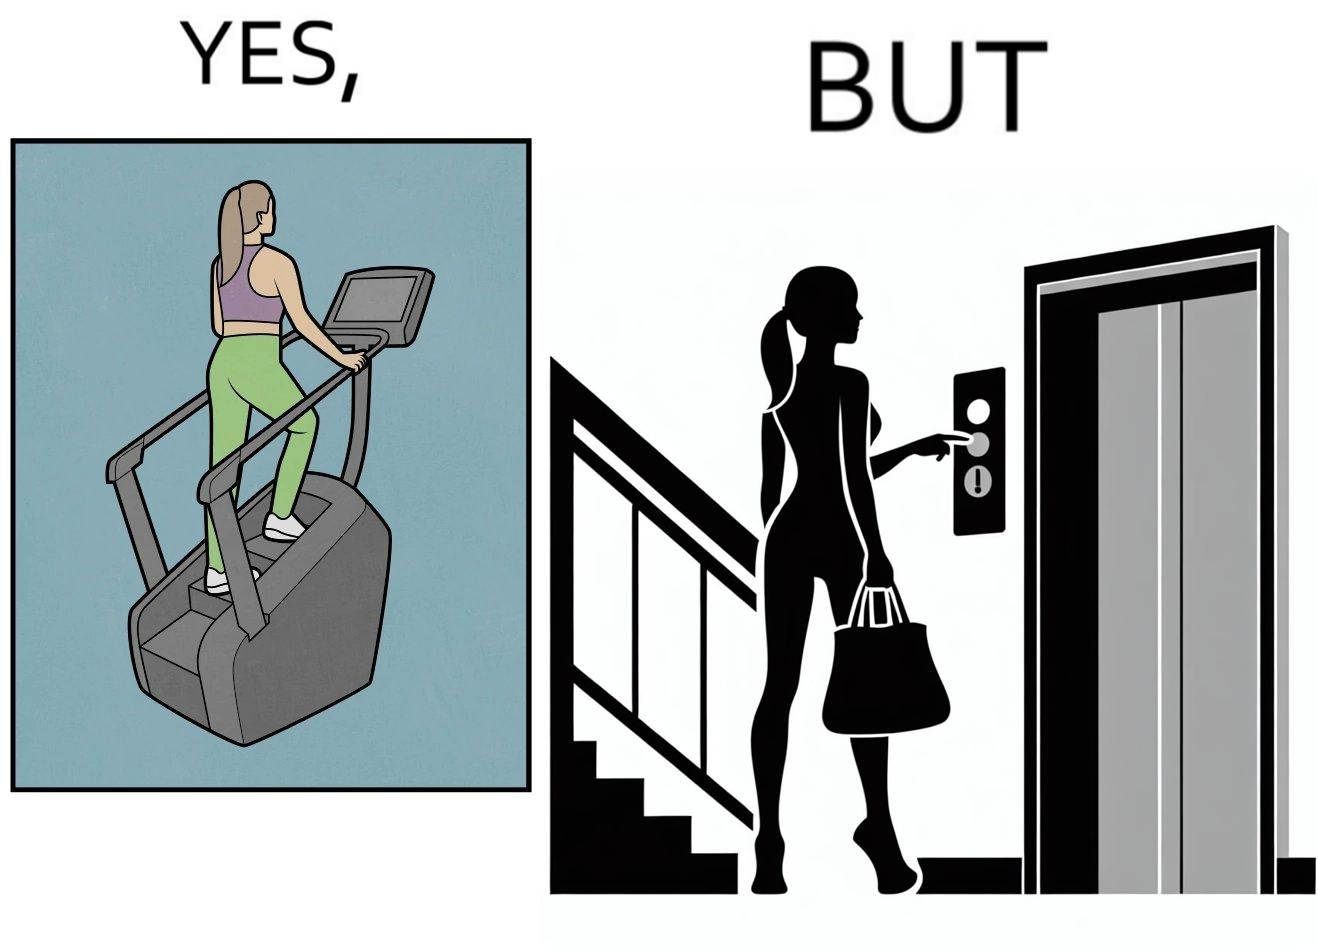Is this a satirical image? Yes, this image is satirical. 